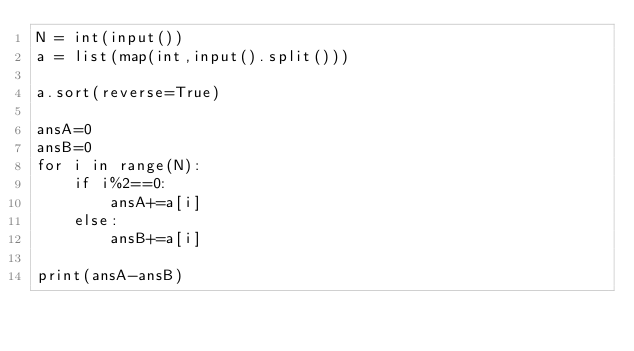Convert code to text. <code><loc_0><loc_0><loc_500><loc_500><_Python_>N = int(input())
a = list(map(int,input().split()))

a.sort(reverse=True)

ansA=0
ansB=0
for i in range(N):
    if i%2==0:
        ansA+=a[i]
    else:
        ansB+=a[i]

print(ansA-ansB)</code> 